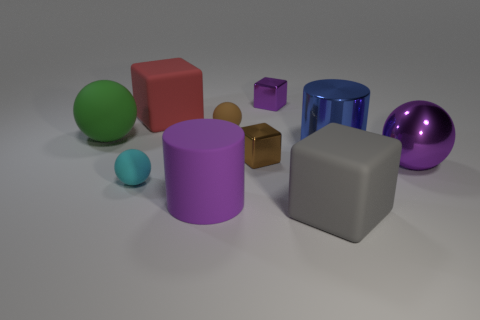Subtract all red balls. Subtract all blue blocks. How many balls are left? 4 Subtract all balls. How many objects are left? 6 Subtract all small brown objects. Subtract all big matte objects. How many objects are left? 4 Add 8 purple shiny things. How many purple shiny things are left? 10 Add 5 large blue shiny cylinders. How many large blue shiny cylinders exist? 6 Subtract 0 yellow cylinders. How many objects are left? 10 